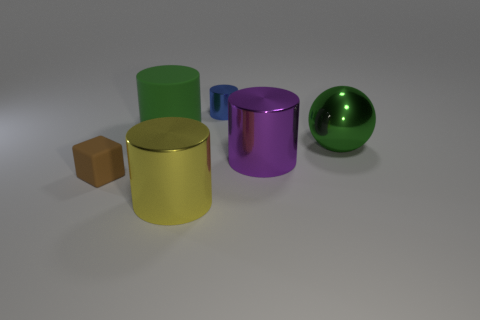Are there fewer matte cylinders right of the large purple shiny cylinder than large cyan rubber things?
Provide a succinct answer. No. The small object right of the yellow cylinder is what color?
Offer a very short reply. Blue. What is the shape of the brown object?
Provide a short and direct response. Cube. Is there a tiny brown matte thing that is in front of the matte thing that is behind the rubber object in front of the large green metal ball?
Make the answer very short. Yes. There is a large thing that is behind the green object right of the big shiny cylinder in front of the brown matte cube; what color is it?
Offer a very short reply. Green. There is a green thing that is the same shape as the small blue metallic thing; what is its material?
Your answer should be compact. Rubber. There is a green thing in front of the cylinder on the left side of the yellow metal cylinder; how big is it?
Your answer should be compact. Large. What is the tiny object that is behind the big matte cylinder made of?
Offer a terse response. Metal. What is the size of the blue object that is made of the same material as the sphere?
Keep it short and to the point. Small. What number of big shiny objects are the same shape as the tiny brown thing?
Provide a succinct answer. 0. 